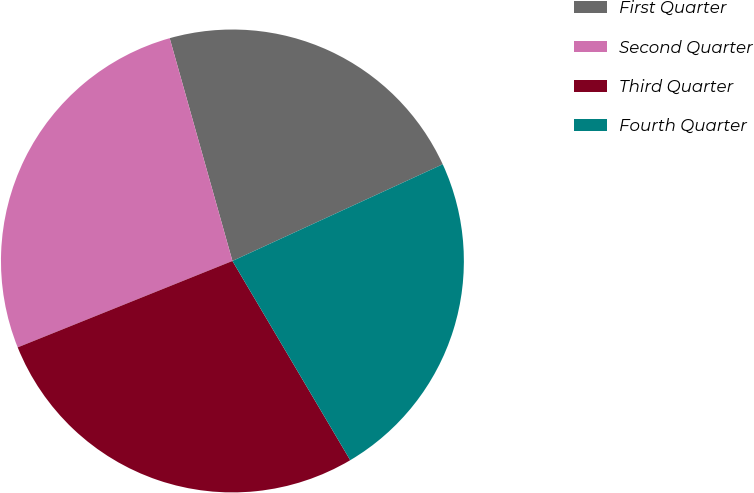Convert chart. <chart><loc_0><loc_0><loc_500><loc_500><pie_chart><fcel>First Quarter<fcel>Second Quarter<fcel>Third Quarter<fcel>Fourth Quarter<nl><fcel>22.51%<fcel>26.72%<fcel>27.41%<fcel>23.36%<nl></chart> 